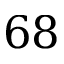Convert formula to latex. <formula><loc_0><loc_0><loc_500><loc_500>6 8</formula> 